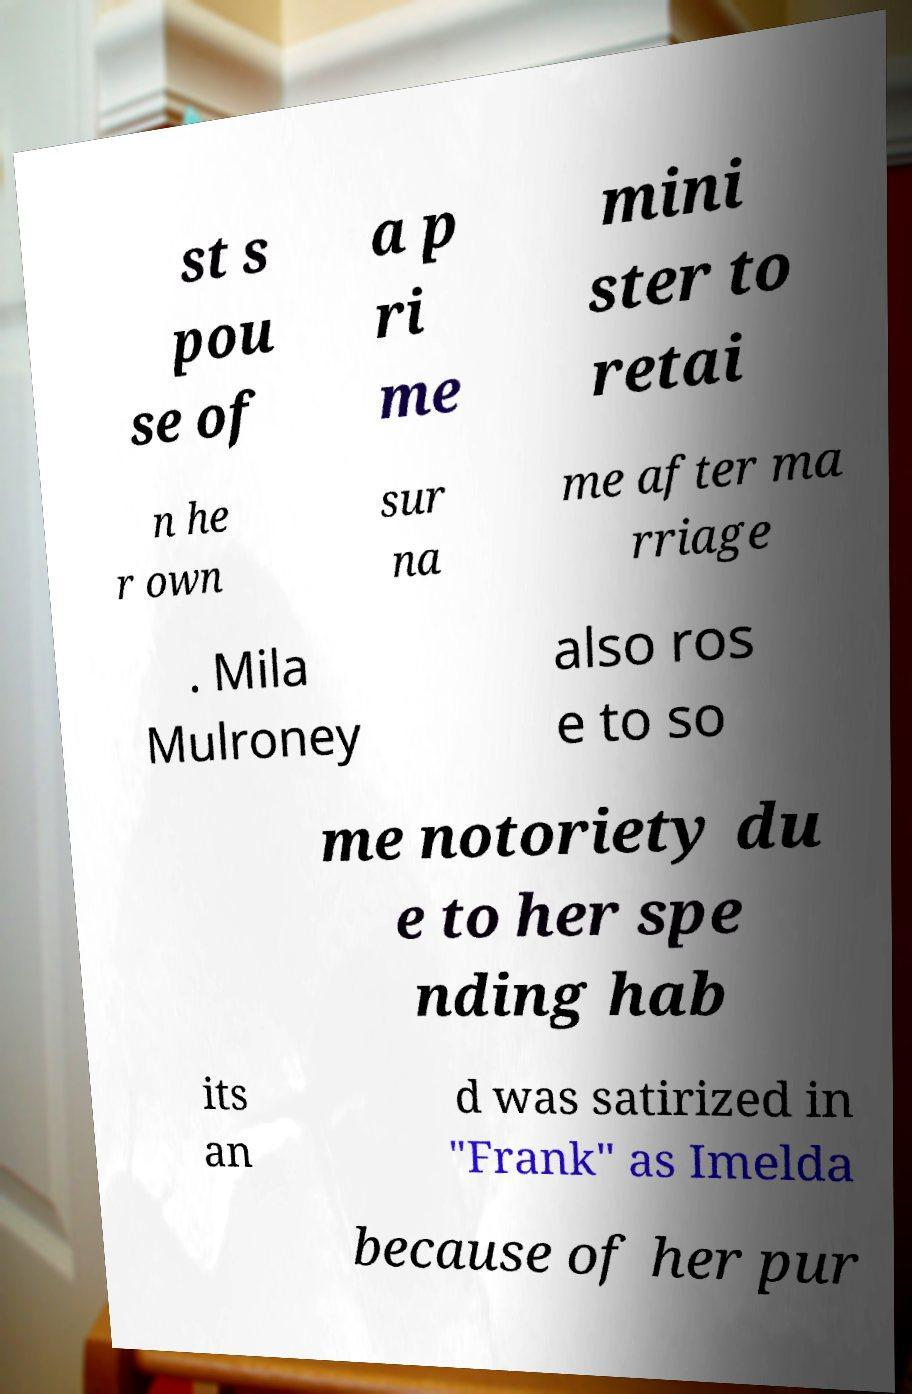For documentation purposes, I need the text within this image transcribed. Could you provide that? st s pou se of a p ri me mini ster to retai n he r own sur na me after ma rriage . Mila Mulroney also ros e to so me notoriety du e to her spe nding hab its an d was satirized in "Frank" as Imelda because of her pur 